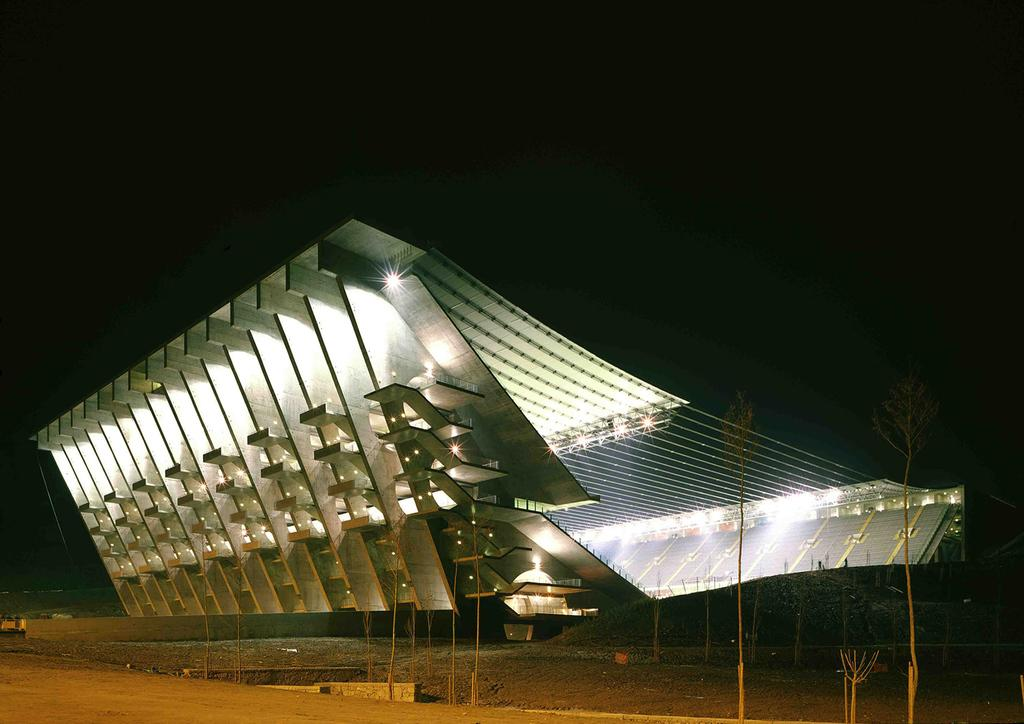What is the main structure in the image? There is a stadium in the image. What can be seen at the bottom of the image? Plants and the ground are visible at the bottom of the image. How would you describe the background of the image? The background of the image is dark. Can you see any waves or bubbles in the image? No, there are no waves or bubbles present in the image. 